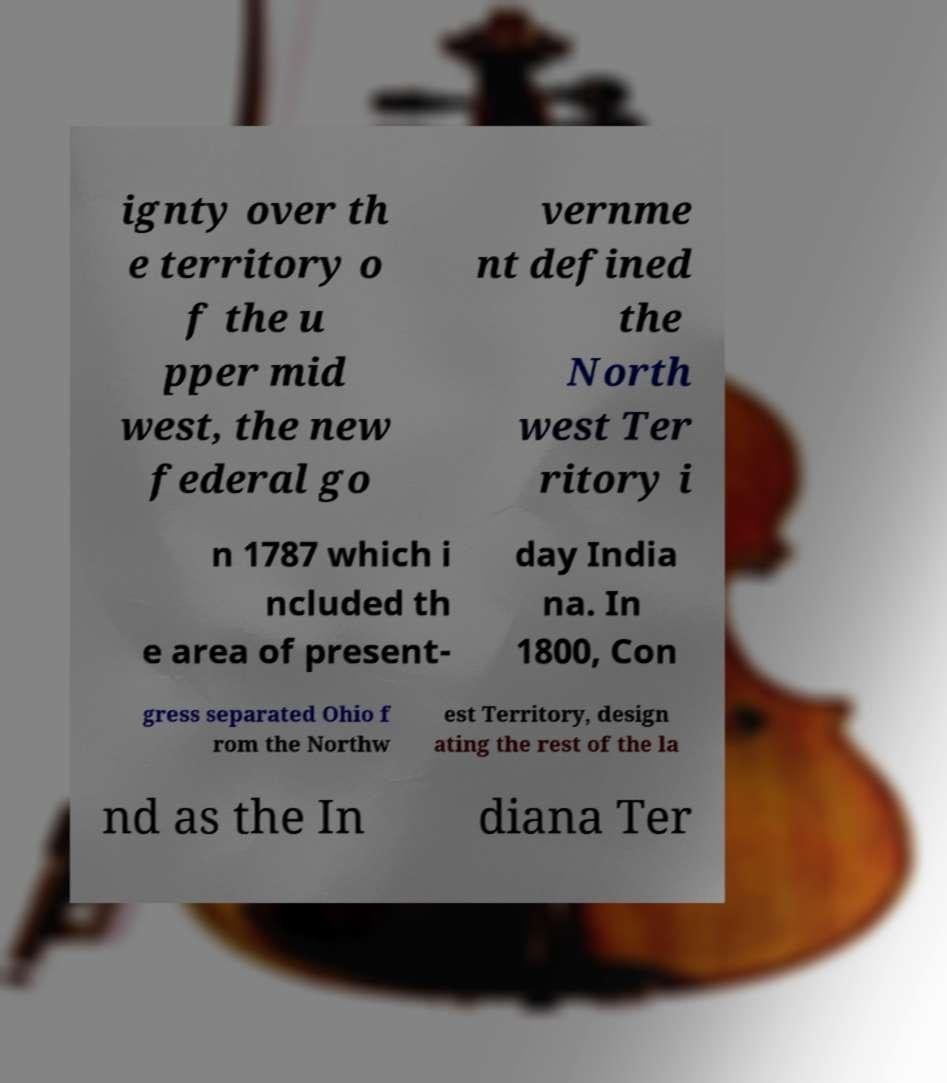What messages or text are displayed in this image? I need them in a readable, typed format. ignty over th e territory o f the u pper mid west, the new federal go vernme nt defined the North west Ter ritory i n 1787 which i ncluded th e area of present- day India na. In 1800, Con gress separated Ohio f rom the Northw est Territory, design ating the rest of the la nd as the In diana Ter 